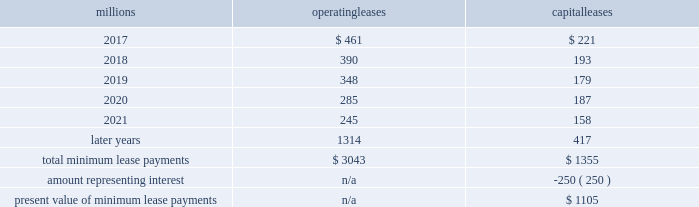17 .
Leases we lease certain locomotives , freight cars , and other property .
The consolidated statements of financial position as of december 31 , 2016 , and 2015 included $ 1997 million , net of $ 1121 million of accumulated depreciation , and $ 2273 million , net of $ 1189 million of accumulated depreciation , respectively , for properties held under capital leases .
A charge to income resulting from the depreciation for assets held under capital leases is included within depreciation expense in our consolidated statements of income .
Future minimum lease payments for operating and capital leases with initial or remaining non-cancelable lease terms in excess of one year as of december 31 , 2016 , were as follows : millions operating leases capital leases .
Approximately 96% ( 96 % ) of capital lease payments relate to locomotives .
Rent expense for operating leases with terms exceeding one month was $ 535 million in 2016 , $ 590 million in 2015 , and $ 593 million in 2014 .
When cash rental payments are not made on a straight-line basis , we recognize variable rental expense on a straight-line basis over the lease term .
Contingent rentals and sub-rentals are not significant .
18 .
Commitments and contingencies asserted and unasserted claims 2013 various claims and lawsuits are pending against us and certain of our subsidiaries .
We cannot fully determine the effect of all asserted and unasserted claims on our consolidated results of operations , financial condition , or liquidity .
To the extent possible , we have recorded a liability where asserted and unasserted claims are considered probable and where such claims can be reasonably estimated .
We do not expect that any known lawsuits , claims , environmental costs , commitments , contingent liabilities , or guarantees will have a material adverse effect on our consolidated results of operations , financial condition , or liquidity after taking into account liabilities and insurance recoveries previously recorded for these matters .
Personal injury 2013 the cost of personal injuries to employees and others related to our activities is charged to expense based on estimates of the ultimate cost and number of incidents each year .
We use an actuarial analysis to measure the expense and liability , including unasserted claims .
The federal employers 2019 liability act ( fela ) governs compensation for work-related accidents .
Under fela , damages are assessed based on a finding of fault through litigation or out-of-court settlements .
We offer a comprehensive variety of services and rehabilitation programs for employees who are injured at work .
Our personal injury liability is not discounted to present value due to the uncertainty surrounding the timing of future payments .
Approximately 94% ( 94 % ) of the recorded liability is related to asserted claims and approximately 6% ( 6 % ) is related to unasserted claims at december 31 , 2016 .
Because of the uncertainty surrounding the ultimate outcome of personal injury claims , it is reasonably possible that future costs to settle these claims may range from approximately $ 290 million to $ 317 million .
We record an accrual at the low end of the range as no amount of loss within the range is more probable than any other .
Estimates can vary over time due to evolving trends in litigation. .
In 2016 what was the percent of the total operating leases that was due including terms greater than 12 months? 
Computations: (535 / (535 + 3043))
Answer: 0.14952. 17 .
Leases we lease certain locomotives , freight cars , and other property .
The consolidated statements of financial position as of december 31 , 2016 , and 2015 included $ 1997 million , net of $ 1121 million of accumulated depreciation , and $ 2273 million , net of $ 1189 million of accumulated depreciation , respectively , for properties held under capital leases .
A charge to income resulting from the depreciation for assets held under capital leases is included within depreciation expense in our consolidated statements of income .
Future minimum lease payments for operating and capital leases with initial or remaining non-cancelable lease terms in excess of one year as of december 31 , 2016 , were as follows : millions operating leases capital leases .
Approximately 96% ( 96 % ) of capital lease payments relate to locomotives .
Rent expense for operating leases with terms exceeding one month was $ 535 million in 2016 , $ 590 million in 2015 , and $ 593 million in 2014 .
When cash rental payments are not made on a straight-line basis , we recognize variable rental expense on a straight-line basis over the lease term .
Contingent rentals and sub-rentals are not significant .
18 .
Commitments and contingencies asserted and unasserted claims 2013 various claims and lawsuits are pending against us and certain of our subsidiaries .
We cannot fully determine the effect of all asserted and unasserted claims on our consolidated results of operations , financial condition , or liquidity .
To the extent possible , we have recorded a liability where asserted and unasserted claims are considered probable and where such claims can be reasonably estimated .
We do not expect that any known lawsuits , claims , environmental costs , commitments , contingent liabilities , or guarantees will have a material adverse effect on our consolidated results of operations , financial condition , or liquidity after taking into account liabilities and insurance recoveries previously recorded for these matters .
Personal injury 2013 the cost of personal injuries to employees and others related to our activities is charged to expense based on estimates of the ultimate cost and number of incidents each year .
We use an actuarial analysis to measure the expense and liability , including unasserted claims .
The federal employers 2019 liability act ( fela ) governs compensation for work-related accidents .
Under fela , damages are assessed based on a finding of fault through litigation or out-of-court settlements .
We offer a comprehensive variety of services and rehabilitation programs for employees who are injured at work .
Our personal injury liability is not discounted to present value due to the uncertainty surrounding the timing of future payments .
Approximately 94% ( 94 % ) of the recorded liability is related to asserted claims and approximately 6% ( 6 % ) is related to unasserted claims at december 31 , 2016 .
Because of the uncertainty surrounding the ultimate outcome of personal injury claims , it is reasonably possible that future costs to settle these claims may range from approximately $ 290 million to $ 317 million .
We record an accrual at the low end of the range as no amount of loss within the range is more probable than any other .
Estimates can vary over time due to evolving trends in litigation. .
In 2016 what was the percent of the future total minimum operating lease payments that was due in 2017? 
Computations: (461 / 3043)
Answer: 0.1515. 17 .
Leases we lease certain locomotives , freight cars , and other property .
The consolidated statements of financial position as of december 31 , 2016 , and 2015 included $ 1997 million , net of $ 1121 million of accumulated depreciation , and $ 2273 million , net of $ 1189 million of accumulated depreciation , respectively , for properties held under capital leases .
A charge to income resulting from the depreciation for assets held under capital leases is included within depreciation expense in our consolidated statements of income .
Future minimum lease payments for operating and capital leases with initial or remaining non-cancelable lease terms in excess of one year as of december 31 , 2016 , were as follows : millions operating leases capital leases .
Approximately 96% ( 96 % ) of capital lease payments relate to locomotives .
Rent expense for operating leases with terms exceeding one month was $ 535 million in 2016 , $ 590 million in 2015 , and $ 593 million in 2014 .
When cash rental payments are not made on a straight-line basis , we recognize variable rental expense on a straight-line basis over the lease term .
Contingent rentals and sub-rentals are not significant .
18 .
Commitments and contingencies asserted and unasserted claims 2013 various claims and lawsuits are pending against us and certain of our subsidiaries .
We cannot fully determine the effect of all asserted and unasserted claims on our consolidated results of operations , financial condition , or liquidity .
To the extent possible , we have recorded a liability where asserted and unasserted claims are considered probable and where such claims can be reasonably estimated .
We do not expect that any known lawsuits , claims , environmental costs , commitments , contingent liabilities , or guarantees will have a material adverse effect on our consolidated results of operations , financial condition , or liquidity after taking into account liabilities and insurance recoveries previously recorded for these matters .
Personal injury 2013 the cost of personal injuries to employees and others related to our activities is charged to expense based on estimates of the ultimate cost and number of incidents each year .
We use an actuarial analysis to measure the expense and liability , including unasserted claims .
The federal employers 2019 liability act ( fela ) governs compensation for work-related accidents .
Under fela , damages are assessed based on a finding of fault through litigation or out-of-court settlements .
We offer a comprehensive variety of services and rehabilitation programs for employees who are injured at work .
Our personal injury liability is not discounted to present value due to the uncertainty surrounding the timing of future payments .
Approximately 94% ( 94 % ) of the recorded liability is related to asserted claims and approximately 6% ( 6 % ) is related to unasserted claims at december 31 , 2016 .
Because of the uncertainty surrounding the ultimate outcome of personal injury claims , it is reasonably possible that future costs to settle these claims may range from approximately $ 290 million to $ 317 million .
We record an accrual at the low end of the range as no amount of loss within the range is more probable than any other .
Estimates can vary over time due to evolving trends in litigation. .
The total minimum payments for operating leases is what percentage of total minimum payments for capital leases? 
Computations: ((3043 / 1355) * 100)
Answer: 224.57565. 17 .
Leases we lease certain locomotives , freight cars , and other property .
The consolidated statements of financial position as of december 31 , 2016 , and 2015 included $ 1997 million , net of $ 1121 million of accumulated depreciation , and $ 2273 million , net of $ 1189 million of accumulated depreciation , respectively , for properties held under capital leases .
A charge to income resulting from the depreciation for assets held under capital leases is included within depreciation expense in our consolidated statements of income .
Future minimum lease payments for operating and capital leases with initial or remaining non-cancelable lease terms in excess of one year as of december 31 , 2016 , were as follows : millions operating leases capital leases .
Approximately 96% ( 96 % ) of capital lease payments relate to locomotives .
Rent expense for operating leases with terms exceeding one month was $ 535 million in 2016 , $ 590 million in 2015 , and $ 593 million in 2014 .
When cash rental payments are not made on a straight-line basis , we recognize variable rental expense on a straight-line basis over the lease term .
Contingent rentals and sub-rentals are not significant .
18 .
Commitments and contingencies asserted and unasserted claims 2013 various claims and lawsuits are pending against us and certain of our subsidiaries .
We cannot fully determine the effect of all asserted and unasserted claims on our consolidated results of operations , financial condition , or liquidity .
To the extent possible , we have recorded a liability where asserted and unasserted claims are considered probable and where such claims can be reasonably estimated .
We do not expect that any known lawsuits , claims , environmental costs , commitments , contingent liabilities , or guarantees will have a material adverse effect on our consolidated results of operations , financial condition , or liquidity after taking into account liabilities and insurance recoveries previously recorded for these matters .
Personal injury 2013 the cost of personal injuries to employees and others related to our activities is charged to expense based on estimates of the ultimate cost and number of incidents each year .
We use an actuarial analysis to measure the expense and liability , including unasserted claims .
The federal employers 2019 liability act ( fela ) governs compensation for work-related accidents .
Under fela , damages are assessed based on a finding of fault through litigation or out-of-court settlements .
We offer a comprehensive variety of services and rehabilitation programs for employees who are injured at work .
Our personal injury liability is not discounted to present value due to the uncertainty surrounding the timing of future payments .
Approximately 94% ( 94 % ) of the recorded liability is related to asserted claims and approximately 6% ( 6 % ) is related to unasserted claims at december 31 , 2016 .
Because of the uncertainty surrounding the ultimate outcome of personal injury claims , it is reasonably possible that future costs to settle these claims may range from approximately $ 290 million to $ 317 million .
We record an accrual at the low end of the range as no amount of loss within the range is more probable than any other .
Estimates can vary over time due to evolving trends in litigation. .
What is the percentage decrease from the approximate maximum of personal injury claims to the approximate minimum of personal injury claims? 
Computations: (((317 - 290) / 317) * 100)
Answer: 8.51735. 